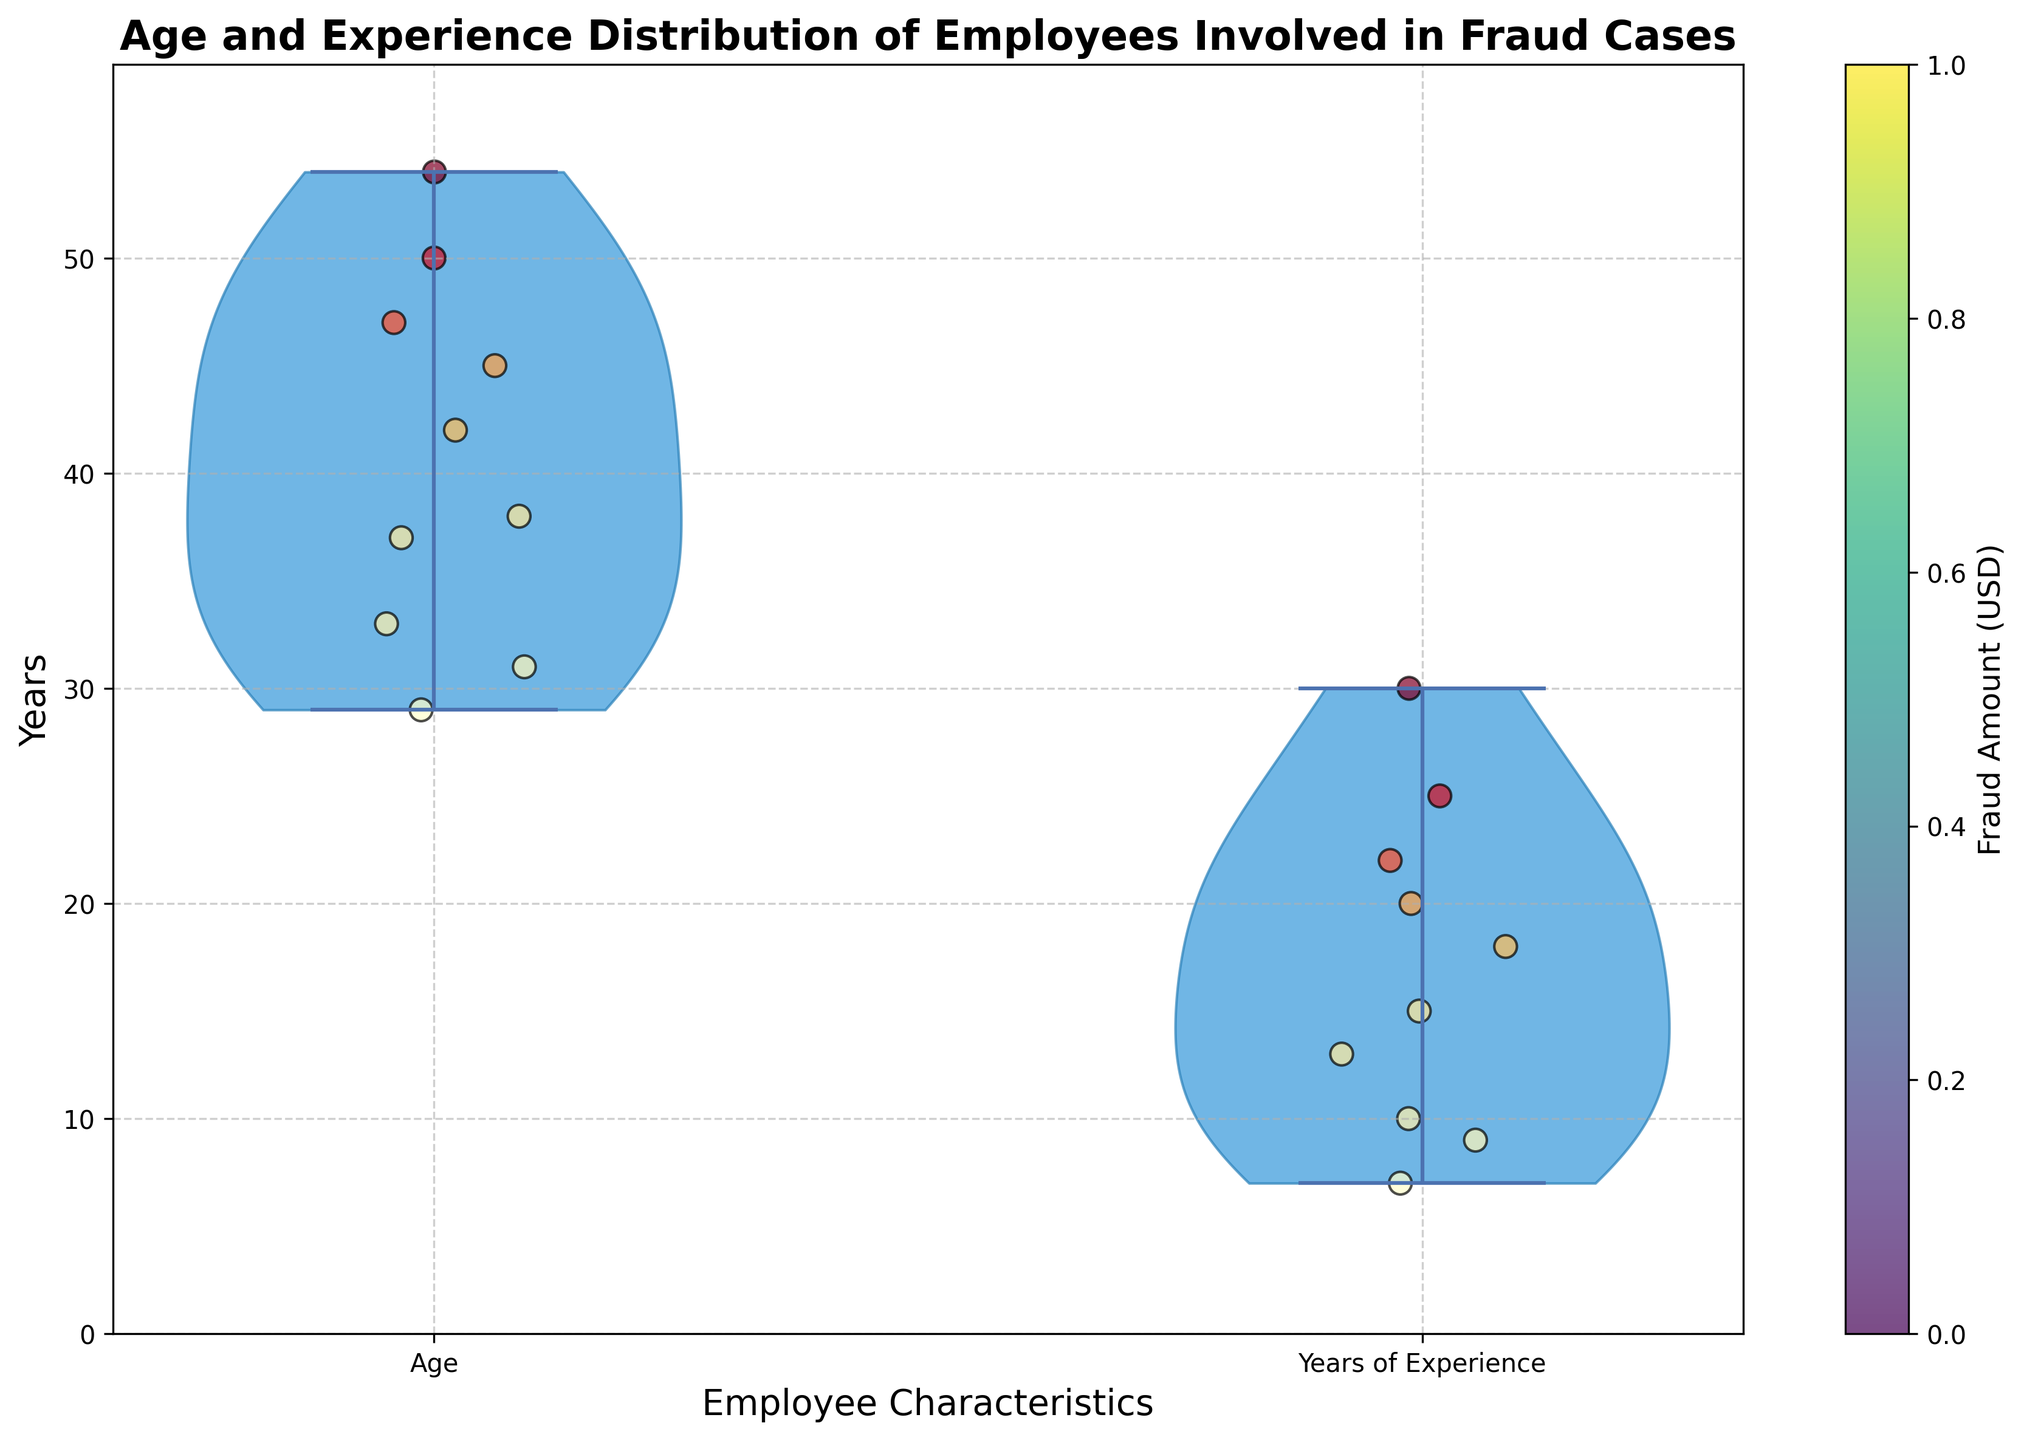What is the title of the chart? The title of the chart is written at the top and reads "Age and Experience Distribution of Employees Involved in Fraud Cases".
Answer: Age and Experience Distribution of Employees Involved in Fraud Cases What do the x-axis labels represent? The x-axis labels represent the employee characteristics being analyzed, which are 'Age' and 'Years of Experience'.
Answer: Age, Years of Experience What do the colors of the jittered points represent? The colors of the jittered points represent the amount of fraud in USD, and this is indicated by the color bar on the right side of the chart.
Answer: Fraud Amount (USD) Which employee characteristic has points that show the highest amount of fraud? By referring to the color intensity of the jittered points and the color bar, the 'Years of Experience' characteristic shows points with the highest fraud amount, as indicated by the color closer to the upper end of the scale.
Answer: Years of Experience What is the approximate age range depicted in the chart? The approximate age range is observed from the bottom to the top of the violin plot for 'Age', which spans from around 29 years to 54 years.
Answer: 29 to 54 years What is the relationship between age and years of experience based on the jittered points? By observing the distribution of points, there is a general trend that older employees tend to have more years of experience, as points representing higher age also appear on the higher side of the experience plot.
Answer: Older employees tend to have more experience What is the maximum value on the y-axis? The maximum value on the y-axis is a few units higher than the highest data point in both groups, which appears to be slightly above 30 years.
Answer: Slightly above 30 years Considering the jittered points, which age appears to have incurred the highest fraud amount? By looking at the color intensity of the points within the 'Age' section, the age around 50 years corresponds to the highest fraud amount, as indicated by a point with a deep color.
Answer: Around 50 years How does the distribution of years of experience compare to the distribution of age? The distribution of years of experience is more spread out from 7 to 30 years, while the age distribution is skewed towards the middle range but less spread.
Answer: Experience is more spread out Based on the chart, what can be concluded about the age and experience of employees involved in the highest fraud cases? Employees involved in the highest fraud cases generally have a high number of years of experience, and they tend to be older, based on the deep-colored points in the upper ranges of both age and experience plots.
Answer: High experience, older employees 